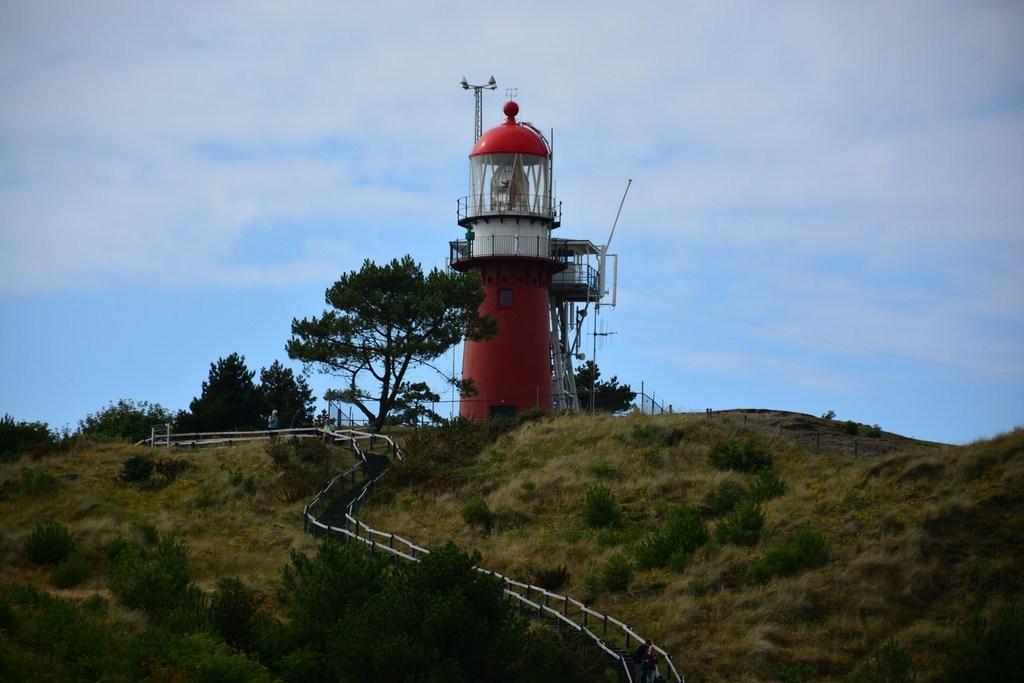How would you summarize this image in a sentence or two? In this picture we can see there is a lighthouse. In front of the lighthouse there are trees and a path. Behind the lighthouse there is a sky. 